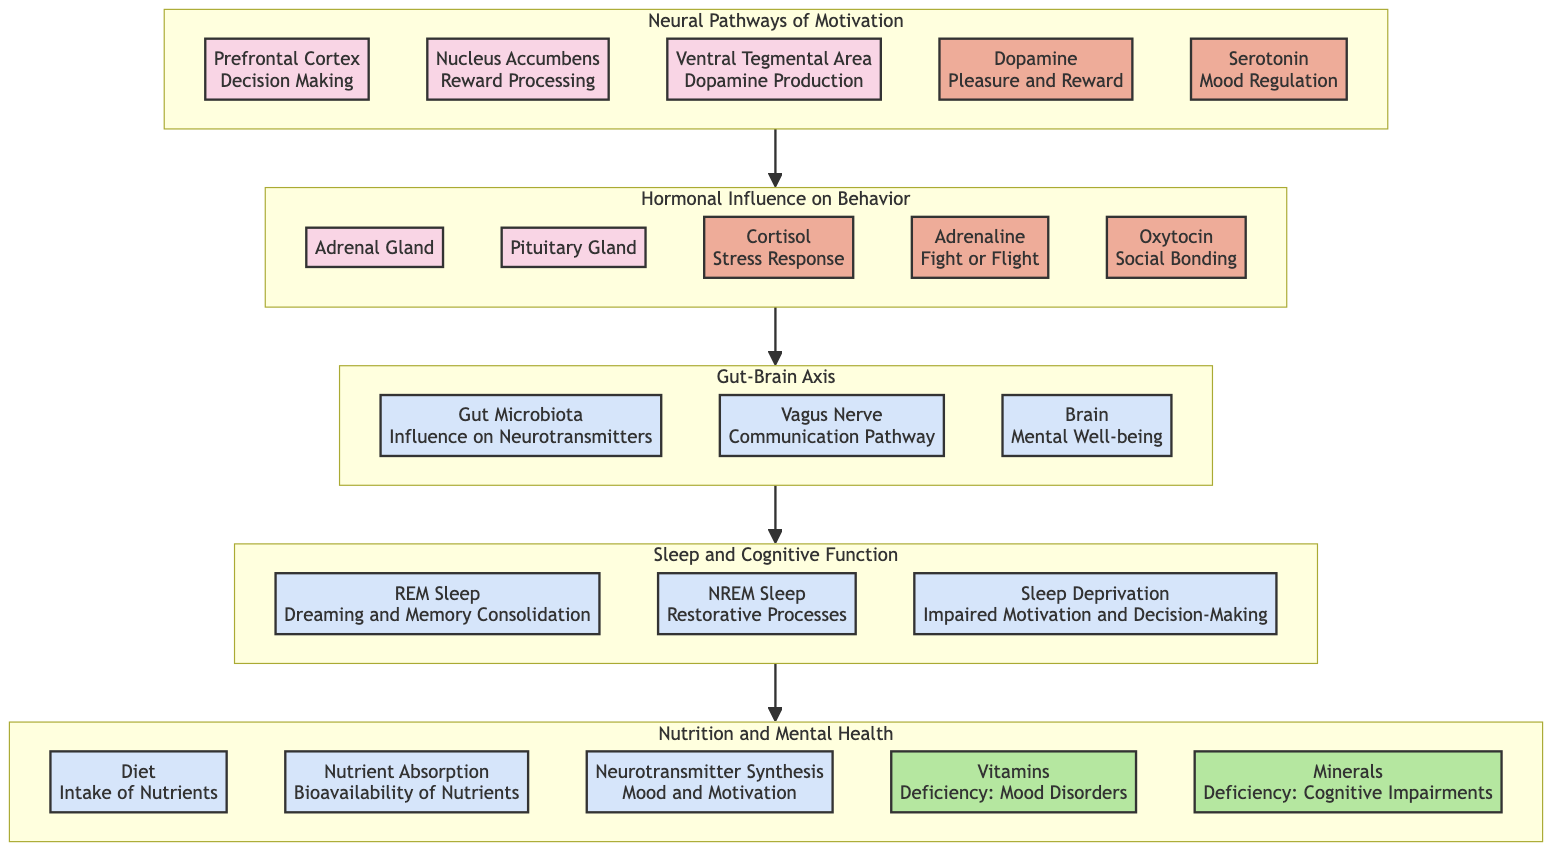What are the brain regions involved in motivation? The diagram lists three brain regions involved in motivation: Prefrontal Cortex, Nucleus Accumbens, and Ventral Tegmental Area.
Answer: Prefrontal Cortex, Nucleus Accumbens, Ventral Tegmental Area Which neurotransmitter is associated with pleasure and reward? According to the diagram, Dopamine is the neurotransmitter linked to pleasure and reward.
Answer: Dopamine How many hormones are indicated in the Hormonal Influence section? The Hormonal Influence section contains three hormones: Cortisol, Adrenaline, and Oxytocin. Therefore, the answer is three.
Answer: Three What is the relationship between the Gut Microbiota and the Brain in the Gut-Brain Axis? The Gut Microbiota influences neurotransmitter production, which subsequently impacts brain function and mental well-being, showing a bidirectional relationship.
Answer: Influence on Neurotransmitters How does sleep deprivation affect motivation according to the diagram? The diagram indicates that sleep deprivation impairs motivation and decision-making, suggesting a negative impact on cognitive functioning.
Answer: Impaired Motivation and Decision-Making Which two nutrients are identified as having deficiencies that affect mood and cognitive impairments? The nutrients identified are Vitamins and Minerals, both listed with their respective deficiencies that lead to mood disorders and cognitive impairments.
Answer: Vitamins, Minerals What is the role of the Vagus Nerve in the Gut-Brain Axis? The Vagus Nerve is shown as a communication pathway that facilitates the interaction between the gut and the brain, highlighting its critical role in transmitting signals that can influence motivation and well-being.
Answer: Communication Pathway Which part of the sleep cycle is associated with dreaming and memory consolidation? REM Sleep is specifically noted in the diagram as being related to dreaming and memory consolidation during the sleep cycle.
Answer: REM Sleep How does the endocrine system influence behavior? The diagram connects the hormonal interactions within the endocrine system to behavioral outcomes such as stress, motivation, and social bonding, emphasizing the impact of hormones in modulating behavior.
Answer: Hormonal Interactions 